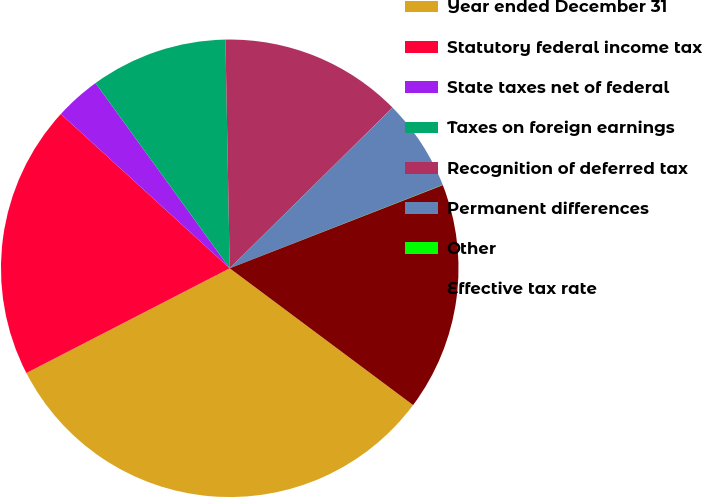Convert chart. <chart><loc_0><loc_0><loc_500><loc_500><pie_chart><fcel>Year ended December 31<fcel>Statutory federal income tax<fcel>State taxes net of federal<fcel>Taxes on foreign earnings<fcel>Recognition of deferred tax<fcel>Permanent differences<fcel>Other<fcel>Effective tax rate<nl><fcel>32.23%<fcel>19.35%<fcel>3.24%<fcel>9.68%<fcel>12.9%<fcel>6.46%<fcel>0.02%<fcel>16.12%<nl></chart> 